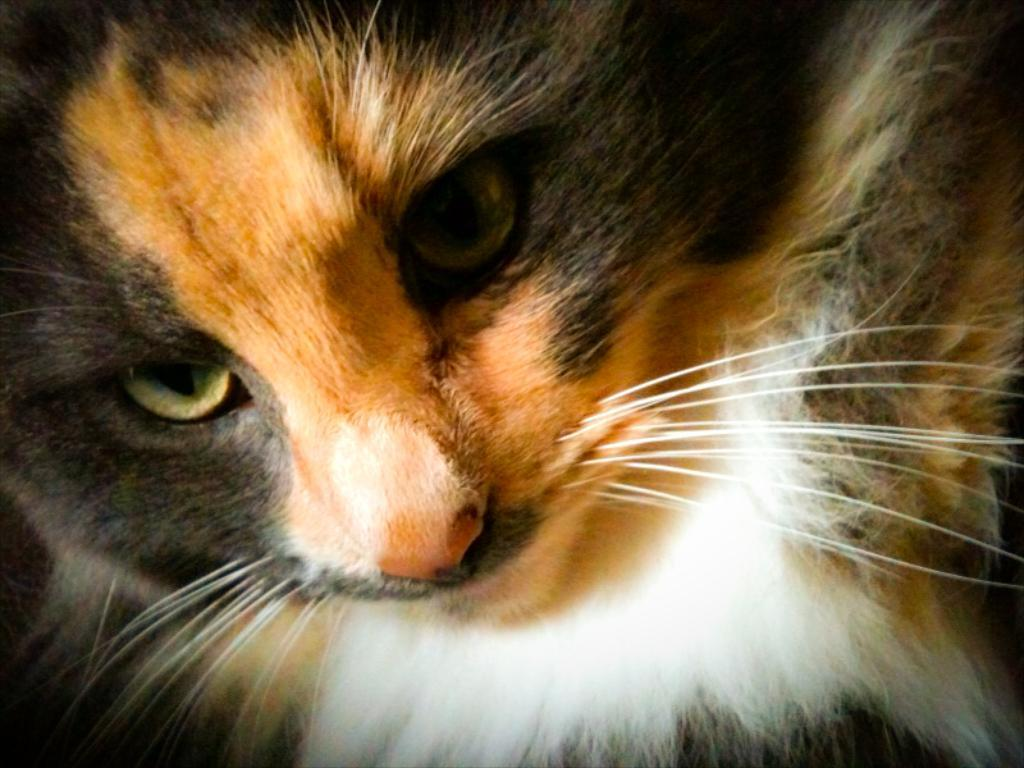What is the main subject of the image? The main subject of the image is a cat's face. Can you describe any specific features of the cat's face? Unfortunately, the image is a zoom-in picture of the cat's face, so we cannot see any specific features beyond the face itself. How many mice are hiding behind the cat's ear in the image? There are no mice present in the image; it is a zoom-in picture of a cat's face. 